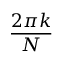<formula> <loc_0><loc_0><loc_500><loc_500>\frac { 2 \pi k } { N }</formula> 